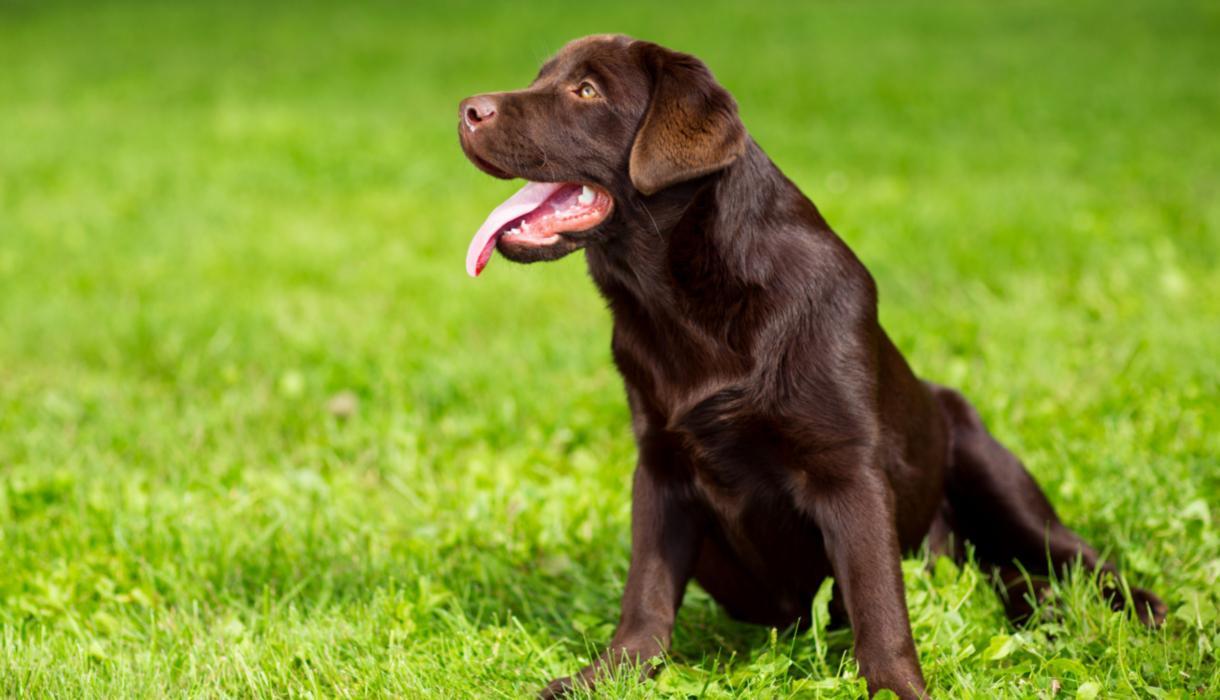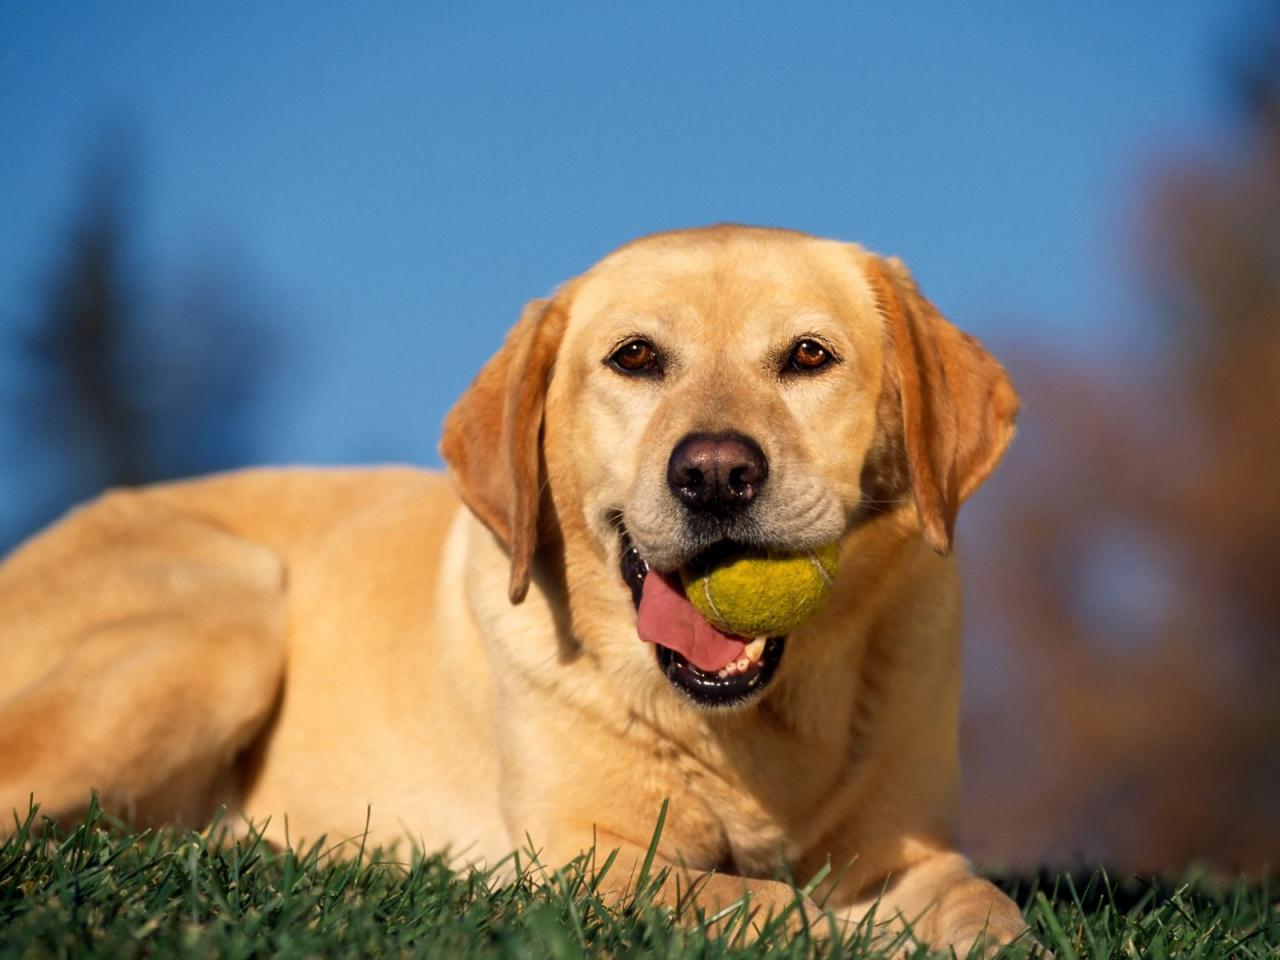The first image is the image on the left, the second image is the image on the right. Considering the images on both sides, is "No dogs have dark fur, one dog is standing on all fours, and at least one dog wears a collar." valid? Answer yes or no. No. The first image is the image on the left, the second image is the image on the right. Considering the images on both sides, is "There is a dog sitting on a grassy lawn" valid? Answer yes or no. Yes. 